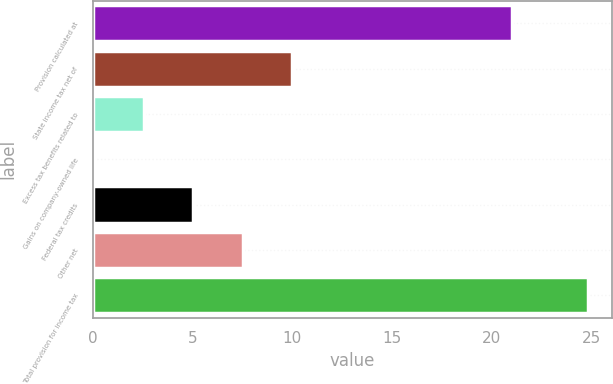Convert chart. <chart><loc_0><loc_0><loc_500><loc_500><bar_chart><fcel>Provision calculated at<fcel>State income tax net of<fcel>Excess tax benefits related to<fcel>Gains on company-owned life<fcel>Federal tax credits<fcel>Other net<fcel>Total provision for income tax<nl><fcel>21<fcel>9.98<fcel>2.57<fcel>0.1<fcel>5.04<fcel>7.51<fcel>24.8<nl></chart> 